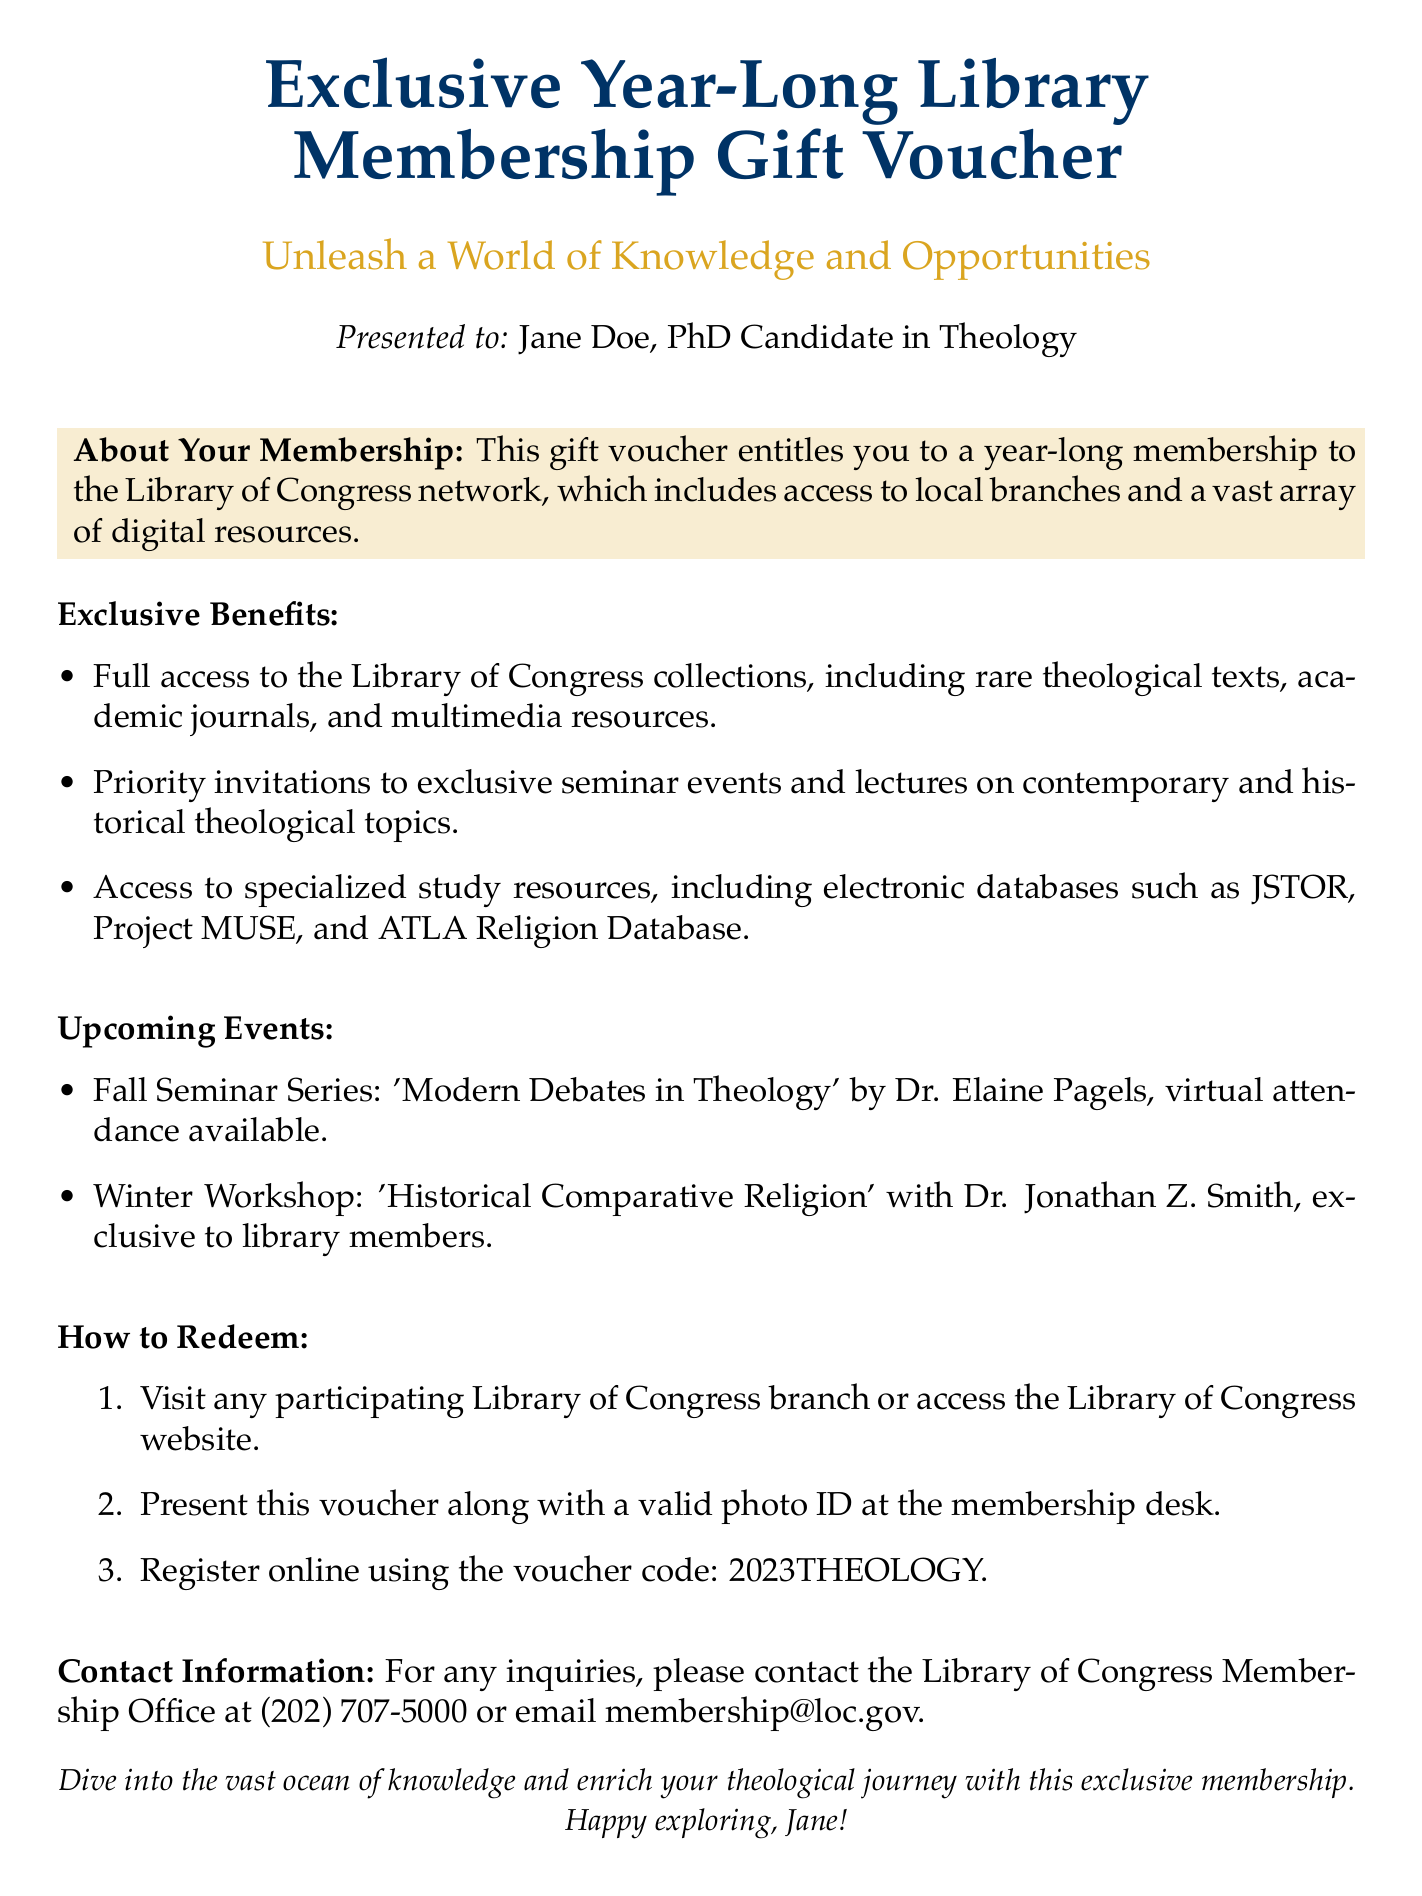What is the membership duration? The membership duration of the voucher is specified as a year-long membership.
Answer: year-long Who is the gift voucher presented to? The document mentions that the gift voucher is presented to Jane Doe.
Answer: Jane Doe What is the voucher code for registration? The voucher code provided in the document for online registration is specified as 2023THEOLOGY.
Answer: 2023THEOLOGY What type of resources does the membership include access to? The membership includes access to collections, journals, and multimedia resources, including rare theological texts.
Answer: rare theological texts What is one of the upcoming events mentioned? The document lists multiple events, one of which is the Fall Seminar Series by Dr. Elaine Pagels.
Answer: Fall Seminar Series: 'Modern Debates in Theology' What should be presented at the membership desk for redemption? The document states that a valid photo ID must be presented along with the voucher at the membership desk.
Answer: valid photo ID What is the contact email for inquiries? The document provides a contact email for inquiries related to the membership, which is membership@loc.gov.
Answer: membership@loc.gov How many exclusive benefits are listed in the document? The document lists three exclusive benefits associated with the membership.
Answer: three What color is referred to in the document for the title? The document specifies the color used for the title as theologydarkblue.
Answer: theologydarkblue 